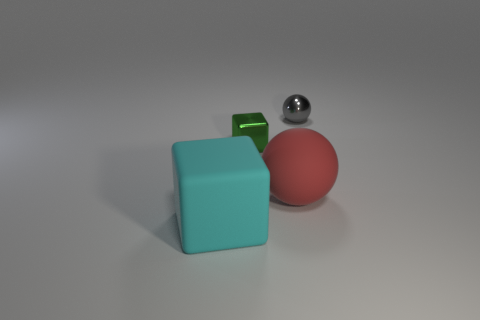Is the number of gray objects less than the number of yellow metal things?
Ensure brevity in your answer.  No. Is the number of matte things greater than the number of big cyan matte cubes?
Offer a terse response. Yes. How many other things are there of the same color as the matte sphere?
Provide a succinct answer. 0. What number of gray objects are behind the ball that is behind the big red sphere?
Make the answer very short. 0. Are there any big cyan objects on the left side of the small block?
Ensure brevity in your answer.  Yes. The big object that is behind the thing that is in front of the big red object is what shape?
Your answer should be very brief. Sphere. Are there fewer cyan cubes behind the tiny metallic block than small blocks in front of the small gray sphere?
Your response must be concise. Yes. There is a tiny metallic thing that is the same shape as the large red object; what is its color?
Ensure brevity in your answer.  Gray. How many objects are in front of the small green metallic block and behind the tiny green object?
Offer a terse response. 0. Is the number of large things that are on the left side of the red ball greater than the number of cyan matte objects that are to the right of the cyan matte object?
Your answer should be compact. Yes. 